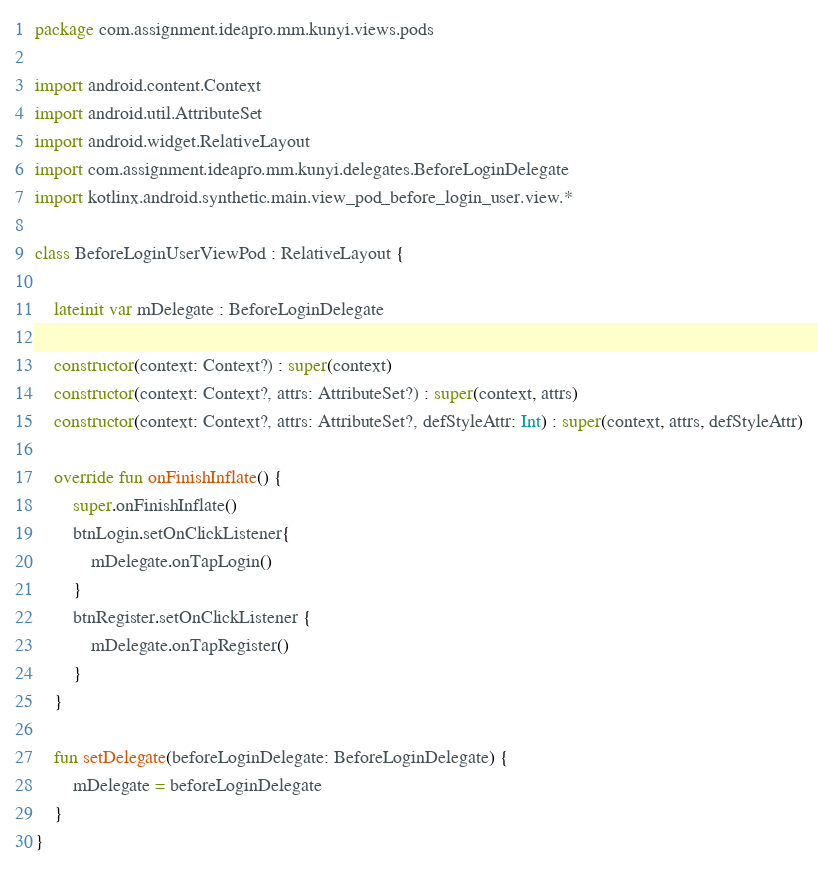Convert code to text. <code><loc_0><loc_0><loc_500><loc_500><_Kotlin_>package com.assignment.ideapro.mm.kunyi.views.pods

import android.content.Context
import android.util.AttributeSet
import android.widget.RelativeLayout
import com.assignment.ideapro.mm.kunyi.delegates.BeforeLoginDelegate
import kotlinx.android.synthetic.main.view_pod_before_login_user.view.*

class BeforeLoginUserViewPod : RelativeLayout {

    lateinit var mDelegate : BeforeLoginDelegate

    constructor(context: Context?) : super(context)
    constructor(context: Context?, attrs: AttributeSet?) : super(context, attrs)
    constructor(context: Context?, attrs: AttributeSet?, defStyleAttr: Int) : super(context, attrs, defStyleAttr)

    override fun onFinishInflate() {
        super.onFinishInflate()
        btnLogin.setOnClickListener{
            mDelegate.onTapLogin()
        }
        btnRegister.setOnClickListener {
            mDelegate.onTapRegister()
        }
    }

    fun setDelegate(beforeLoginDelegate: BeforeLoginDelegate) {
        mDelegate = beforeLoginDelegate
    }
}</code> 